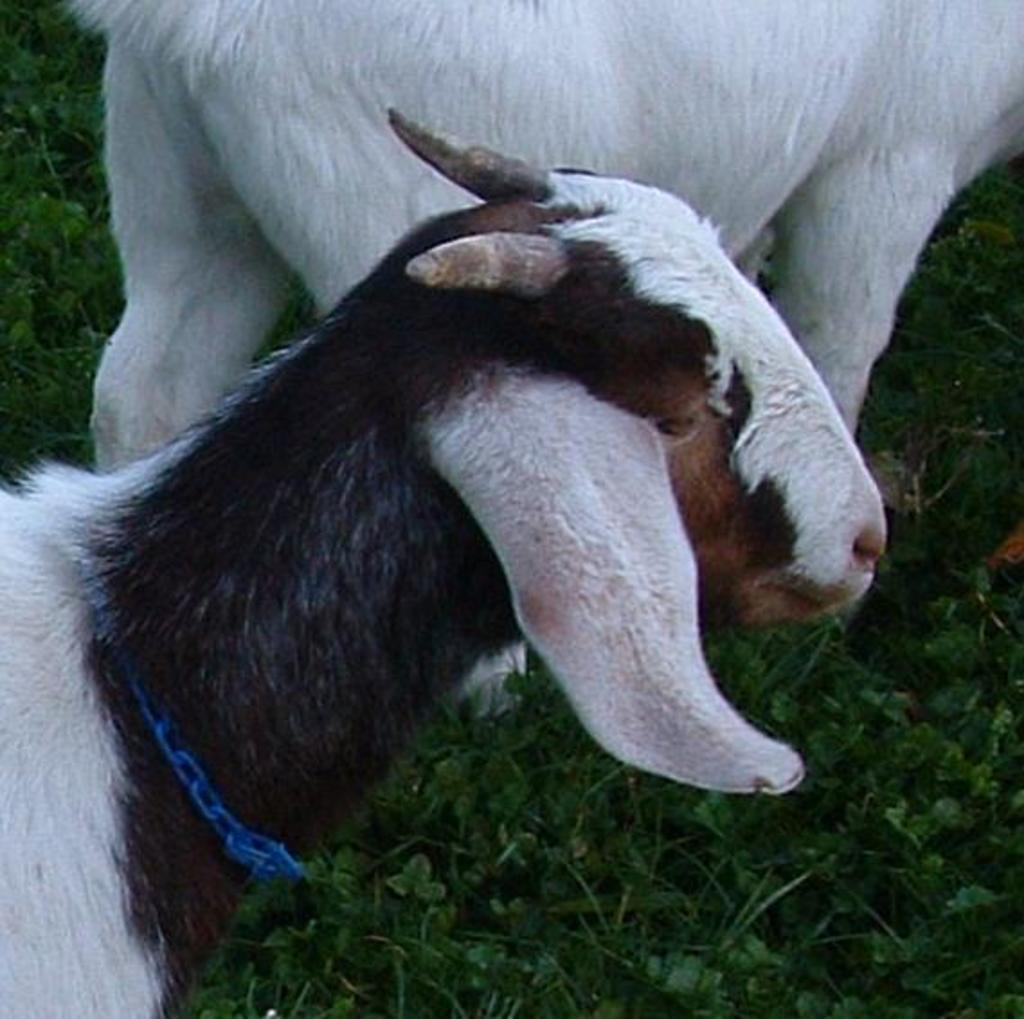What type of vegetation can be seen in the image? There is grass in the image. What animals are present in the image? There are two goats in the image. What type of polish is being applied to the carriage in the image? There is no carriage or polish present in the image; it features grass and two goats. 